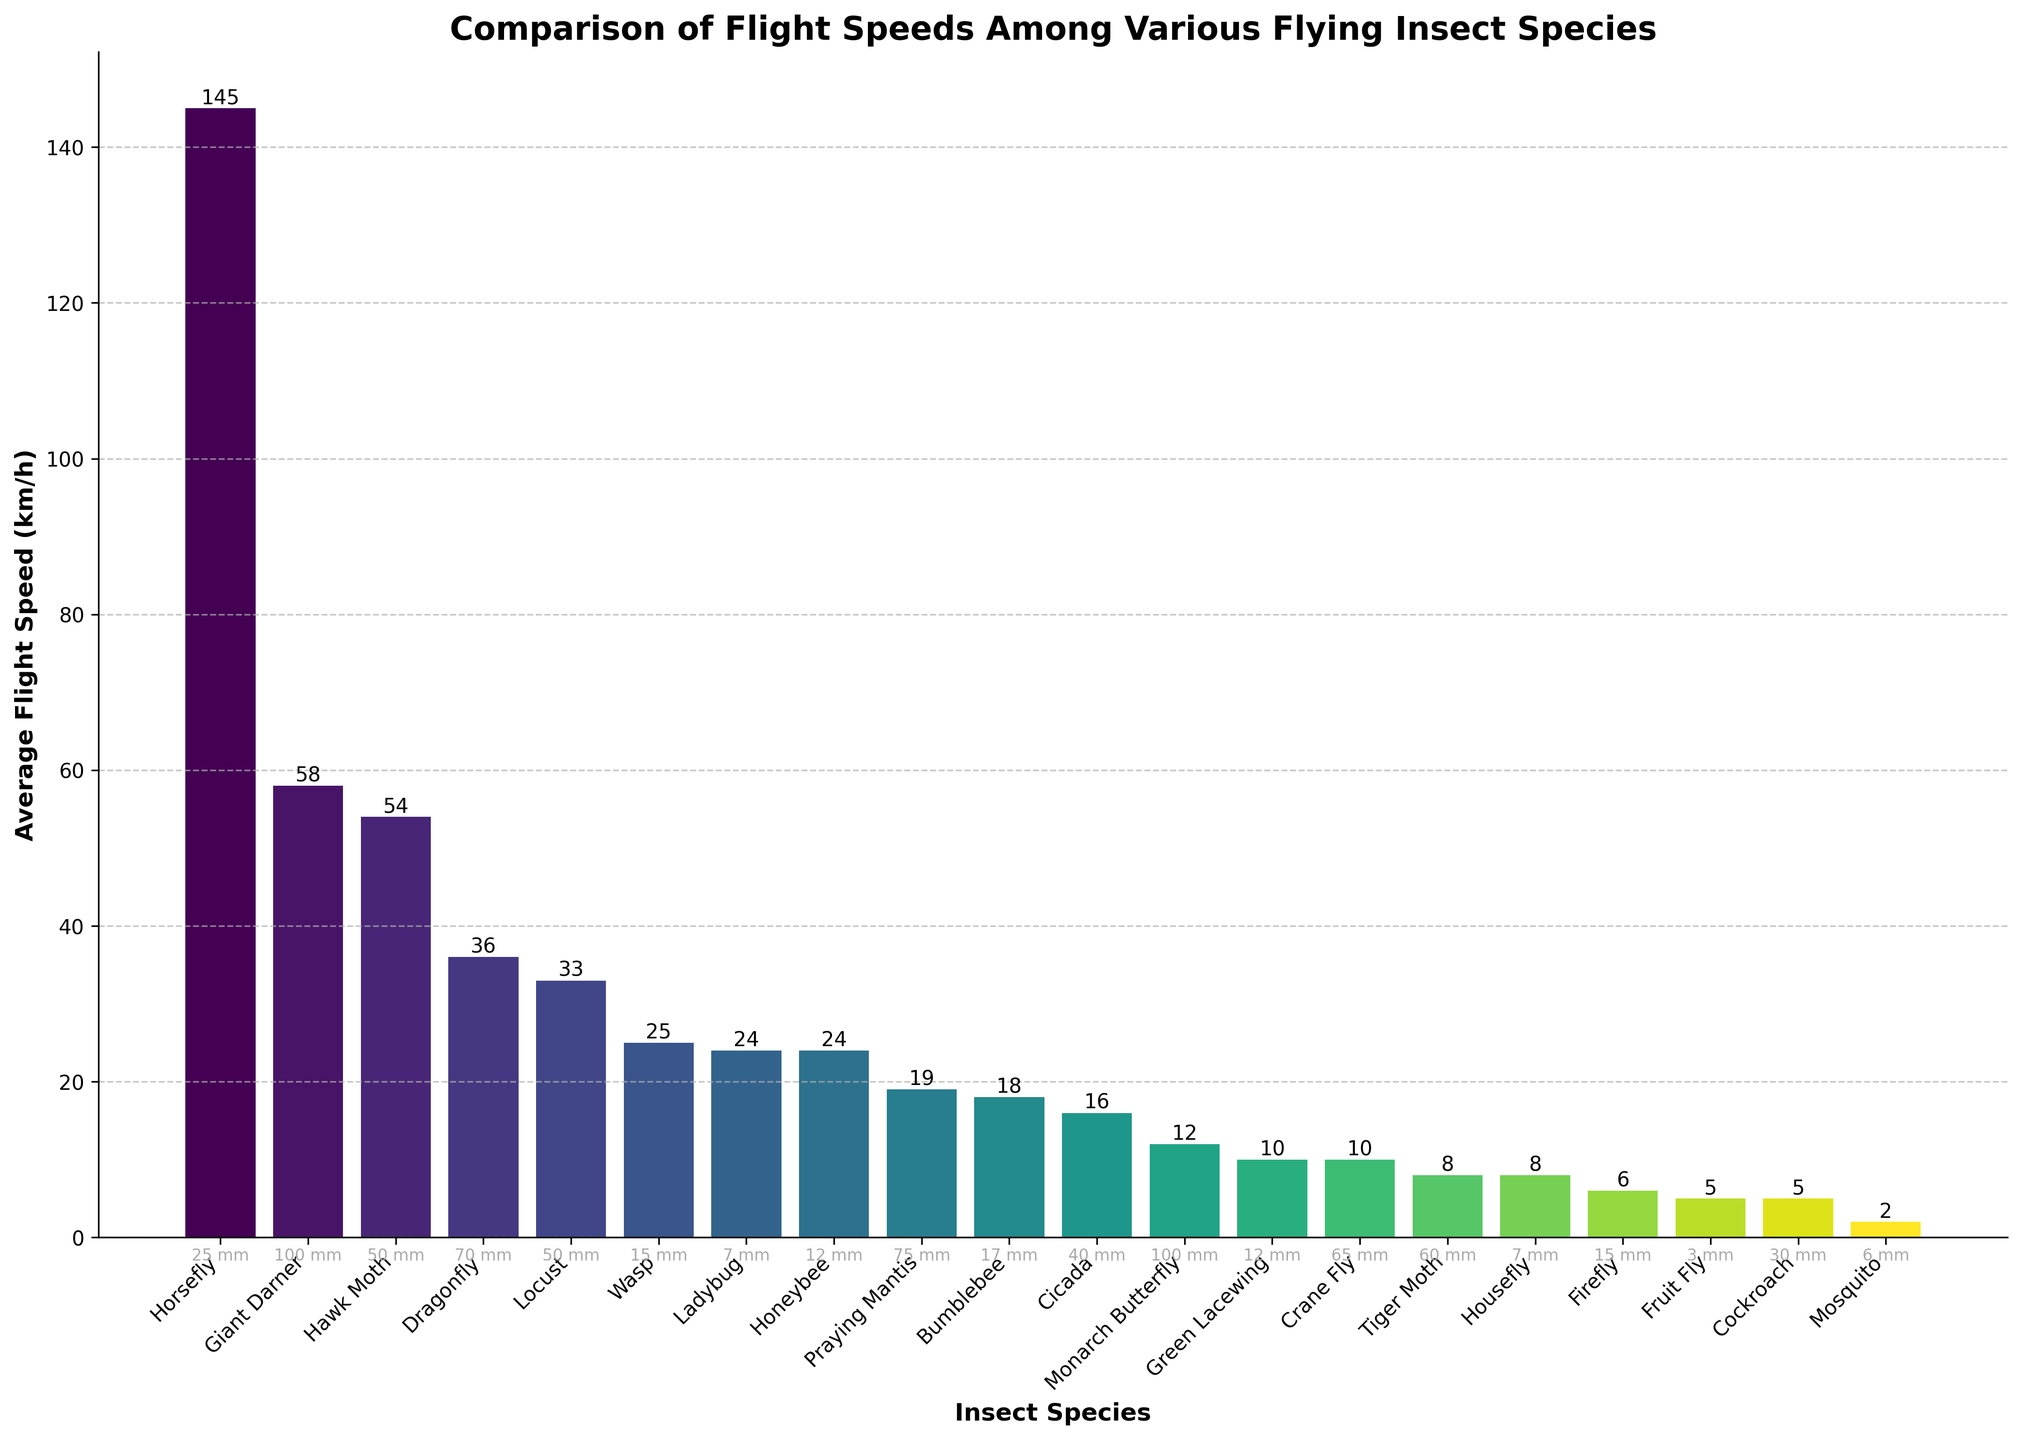Which insect has the highest average flight speed? The bar representing the 'Horsefly' has the tallest height, indicating it has the highest average flight speed among the listed insects.
Answer: Horsefly Which two insects have the same average flight speed? From the figure, the bars for 'Honeybee' and 'Ladybug' both reach the height of 24 km/h, showing they have the same flight speed.
Answer: Honeybee and Ladybug What is the difference in flight speed between the slowest and fastest insects? The 'Mosquito' has the lowest bar at 2 km/h, and the 'Horsefly' has the highest bar at 145 km/h. The difference is 145 km/h - 2 km/h = 143 km/h.
Answer: 143 km/h How many insects have a flight speed greater than 30 km/h? The bars representing 'Dragonfly', 'Hawk Moth', 'Horsefly', 'Giant Darner', and 'Locust' are above the 30 km/h mark. Counting these, we get a total of 5 insects.
Answer: 5 Compare the average flight speed of insects with a body size of 50 mm. Which one is faster? The 'Hawk Moth' and 'Locust' both have body sizes of 50 mm. Comparing their heights on the chart, 'Hawk Moth' (54 km/h) is faster than 'Locust' (33 km/h).
Answer: Hawk Moth Which insect species has a larger body size but a lower average flight speed than the 'Crane Fly'? The 'Praying Mantis' has a body size of 75 mm, which is larger than 'Crane Fly's 65 mm. The 'Praying Mantis' has a flight speed of 19 km/h which is lower than 'Crane Fly's 10 km/h.
Answer: Praying Mantis What is the combined flight speed of the 'Bumblebee', 'Wasp', and 'Firefly'? The flight speeds are 'Bumblebee': 18 km/h, 'Wasp': 25 km/h, and 'Firefly': 6 km/h. Summing them up, we get 18 + 25 + 6 = 49 km/h.
Answer: 49 km/h Which insect averages the same flight speed as the 'Crane Fly' but has a smaller body size? Both 'Crane Fly' and 'Green Lacewing' have an average flight speed of 10 km/h. The 'Green Lacewing' is smaller at 12 mm compared to 'Crane Fly's 65 mm.
Answer: Green Lacewing What is the average flight speed of insects with a body size of less than 10 mm? 'Fruit Fly' (5 km/h), 'Housefly' (8 km/h), 'Ladybug' (24 km/h), and 'Mosquito' (2 km/h). Average speed = (5 + 8 + 24 + 2) / 4 = 9.75 km/h.
Answer: 9.75 km/h 